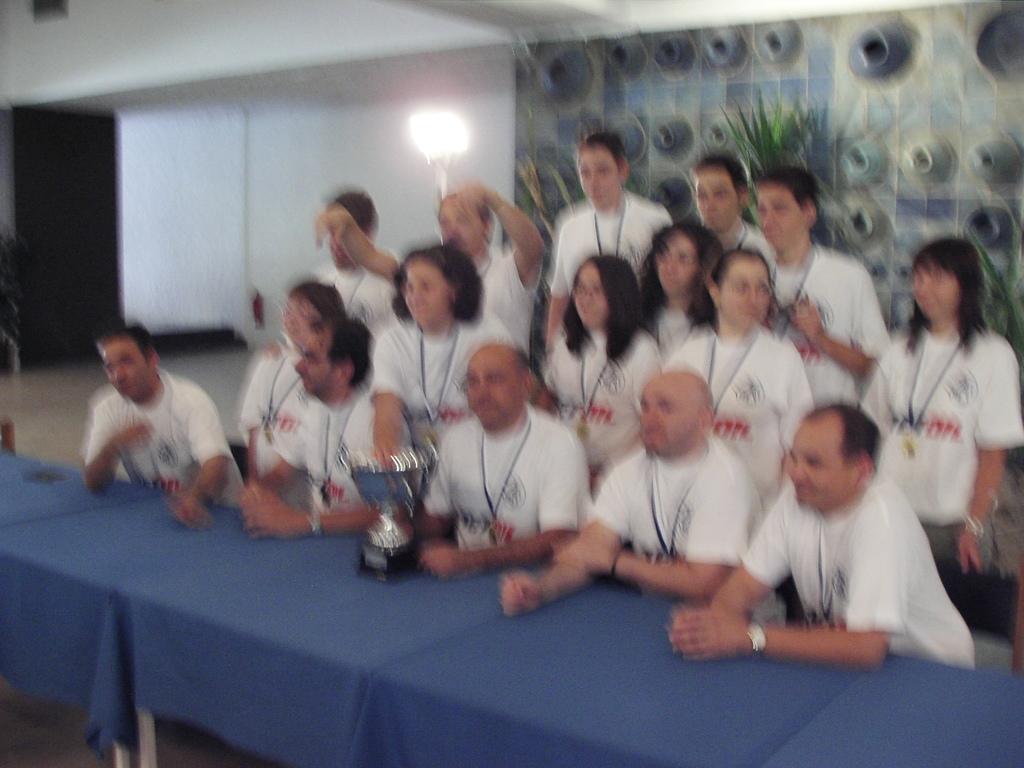In one or two sentences, can you explain what this image depicts? In this image, I can see few people standing and few people sitting. These are the tables, which are covered with the clothes. It looks like a trophy, which is placed on a table. In the background, I can see a lamp and the wall. 